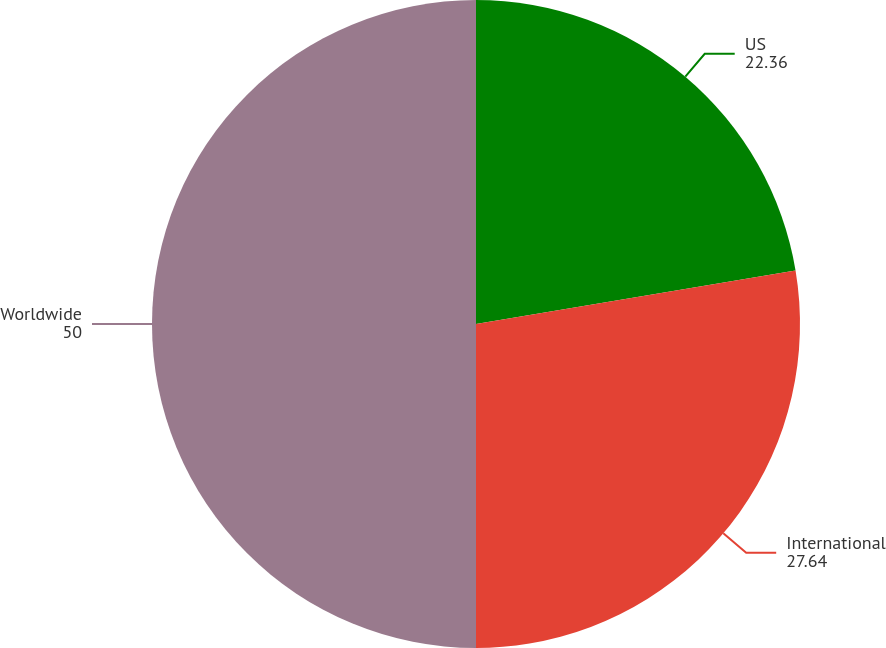Convert chart to OTSL. <chart><loc_0><loc_0><loc_500><loc_500><pie_chart><fcel>US<fcel>International<fcel>Worldwide<nl><fcel>22.36%<fcel>27.64%<fcel>50.0%<nl></chart> 